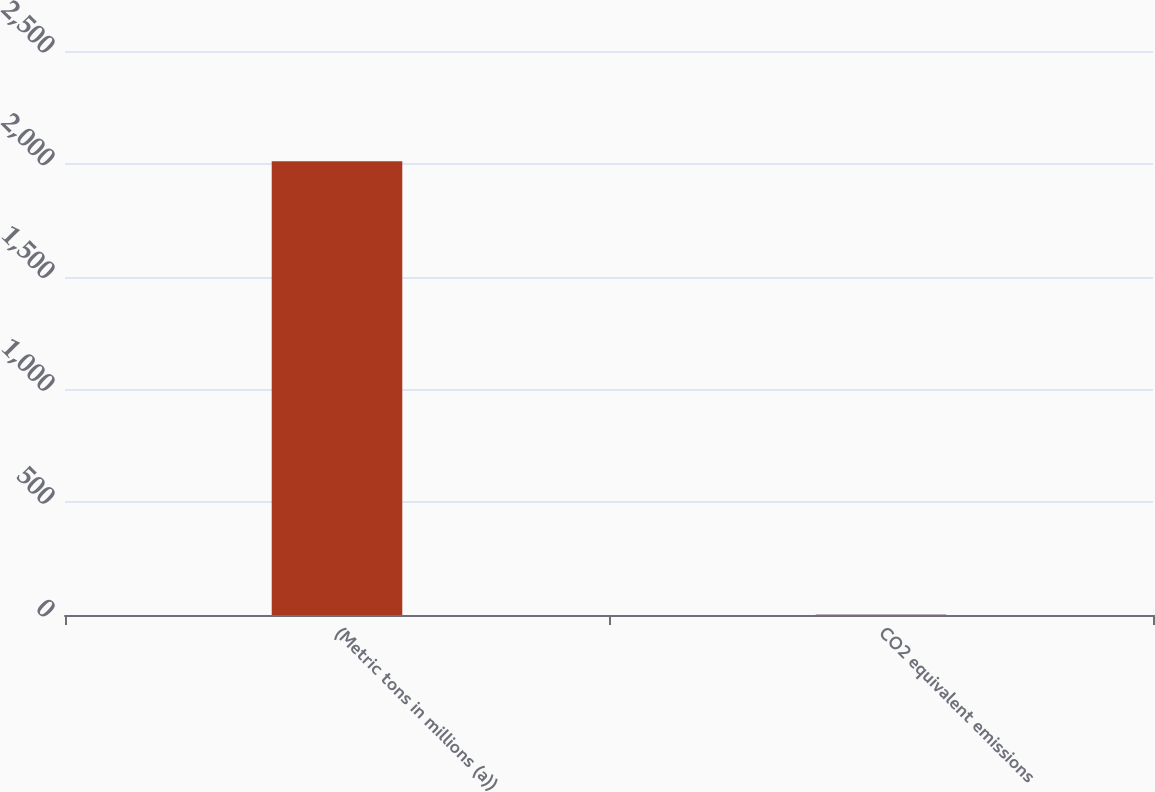Convert chart to OTSL. <chart><loc_0><loc_0><loc_500><loc_500><bar_chart><fcel>(Metric tons in millions (a))<fcel>CO2 equivalent emissions<nl><fcel>2011<fcel>3.4<nl></chart> 